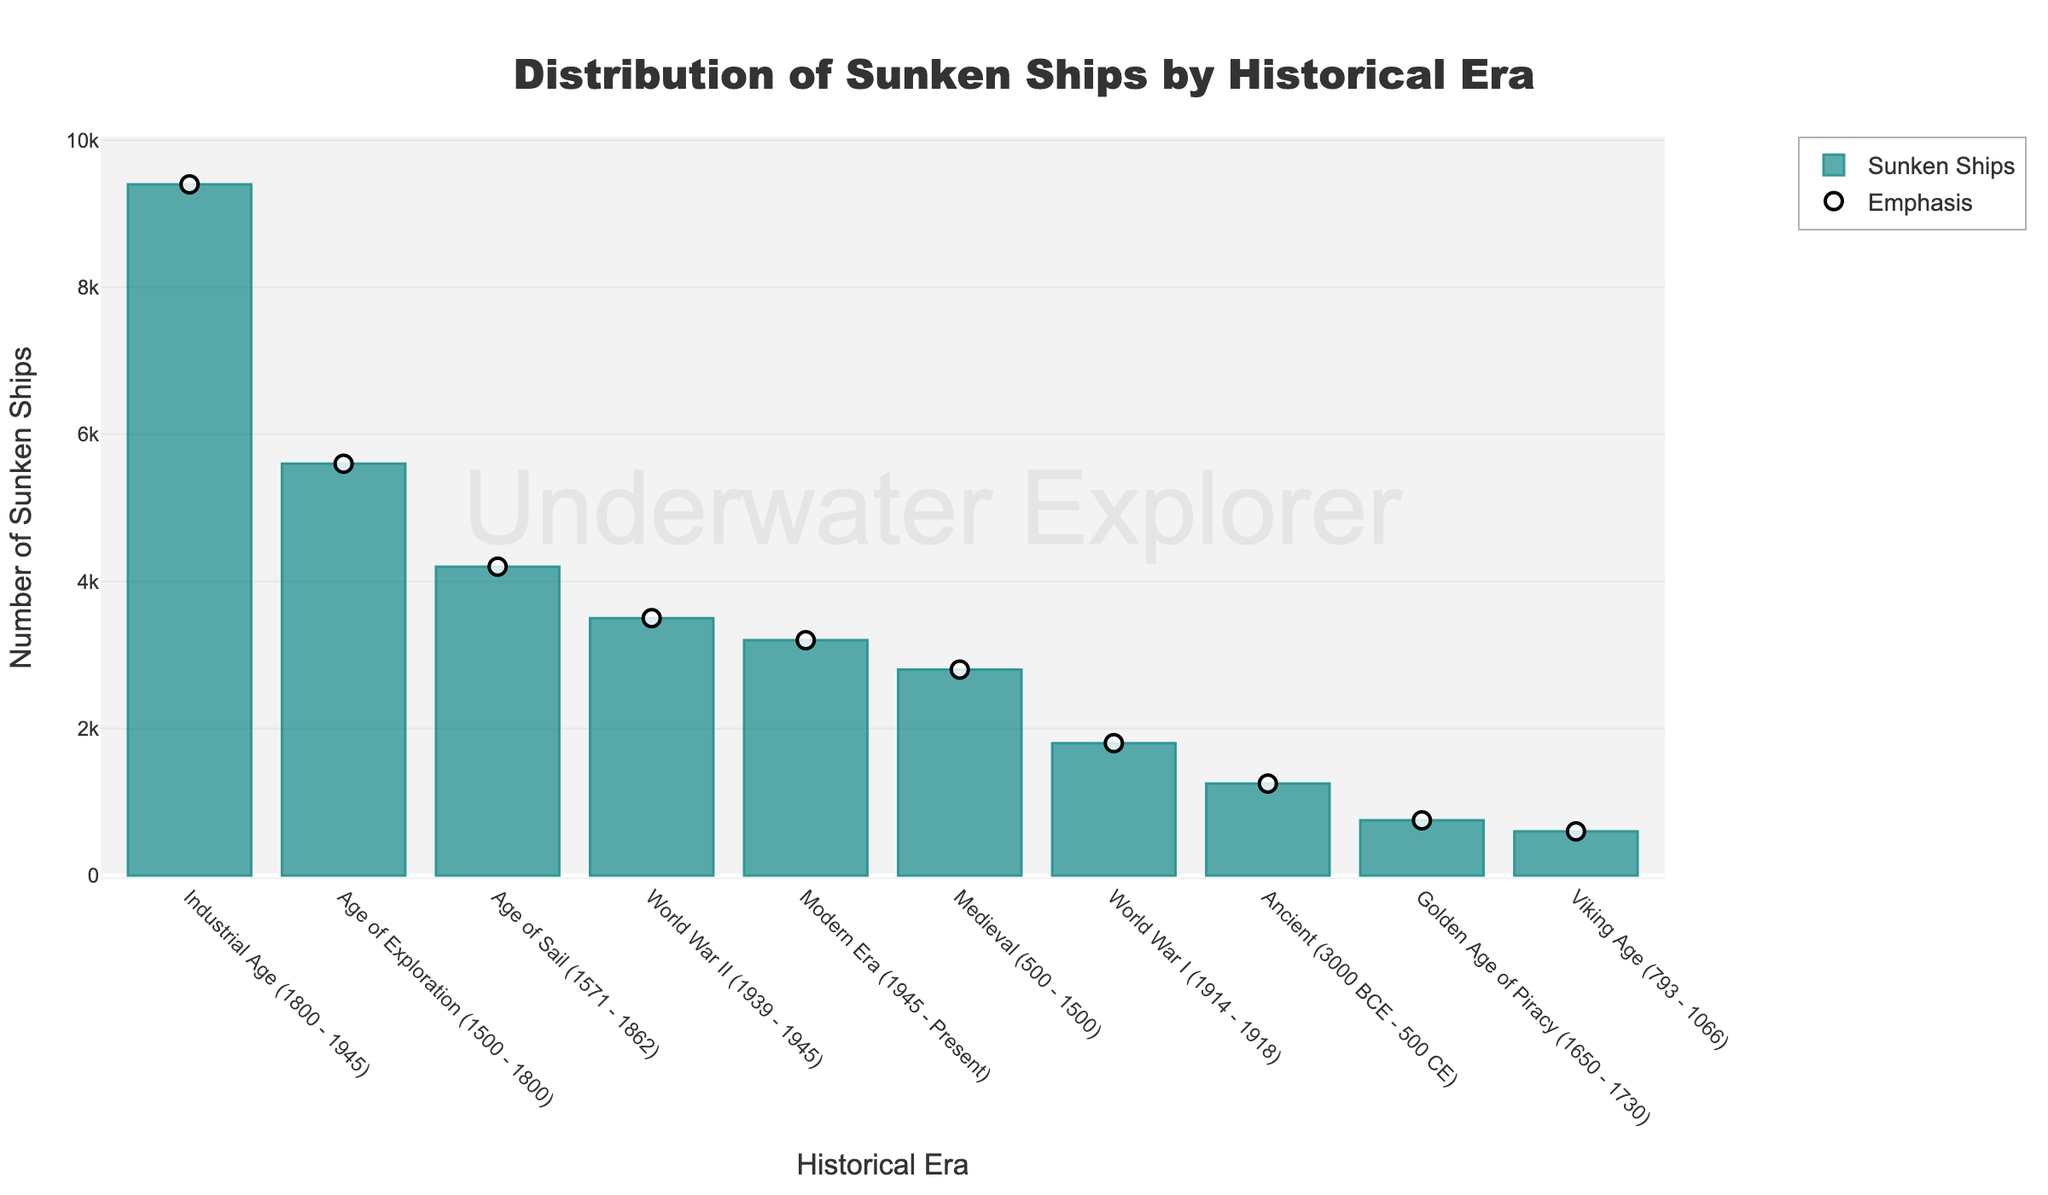What historical era has the highest number of sunken ships? Identify the tallest bar in the bar chart, which represents the era with the most sunken ships. The highest bar corresponds to the "Industrial Age (1800 - 1945)" with 9400 ships.
Answer: Industrial Age (1800 - 1945) Which two historical eras have the fewest sunken ships combined? Examine the bars and find the smallest bars. The "Viking Age (793 - 1066)" and the "Golden Age of Piracy (1650 - 1730)" have the fewest ships, with 600 and 750 ships respectively. Add these numbers: 600 + 750 = 1350 ships.
Answer: Viking Age and Golden Age of Piracy, 1350 ships How many more sunken ships are there in the Age of Exploration compared to the Medieval era? Locate the bars for the "Age of Exploration (1500 - 1800)" and "Medieval (500 - 1500)" eras. The number of sunken ships in these eras is 5600 and 2800 respectively. Subtract the smaller value from the larger: 5600 - 2800 = 2800 ships.
Answer: 2800 ships What is the average number of sunken ships in the Industrial Age, World War I, and World War II eras? Identify the bars for the "Industrial Age (1800 - 1945)" (9400 ships), "World War I (1914 - 1918)" (1800 ships), and "World War II (1939 - 1945)" (3500 ships). Add these numbers: 9400 + 1800 + 3500 = 14700 ships. Divide by the number of eras, which is 3: 14700 / 3 = 4900 ships.
Answer: 4900 ships Which era has fewer sunken ships: Modern Era or World War II? Compare the heights of the bars for "Modern Era (1945 - Present)" and "World War II (1939 - 1945)". The Modern Era has 3200 ships and World War II has 3500 ships. Since 3200 < 3500, the Modern Era has fewer sunken ships.
Answer: Modern Era In which era are the number of sunken ships closer to the median value of all the eras? First, determine the median value. List the number of ships in ascending order: 600, 750, 1250, 1800, 2800, 3200, 3500, 4200, 5600, 9400. The middle values are 2800 and 3200, so the median is (2800 + 3200) / 2 = 3000 ships. Assess which era's ship count is closest to 3000. The era closest to 3000 is the "Modern Era (1945 - Present)" with 3200 ships.
Answer: Modern Era (1945 - Present) Compare the number of sunken ships in the Ancient and Age of Sail eras; which one has more? Look at the bars for the "Ancient (3000 BCE - 500 CE)" and "Age of Sail (1571 - 1862)" eras. The Ancient era has 1250 ships, and the Age of Sail has 4200 ships. Since 4200 > 1250, the Age of Sail has more sunken ships.
Answer: Age of Sail What proportion of sunken ships occurred during the Age of Exploration out of the total number of ships in the Age of Exploration, Age of Sail, and Golden Age of Piracy combined? Add the number of ships in the Age of Exploration (5600), Age of Sail (4200), and Golden Age of Piracy (750): 5600 + 4200 + 750 = 10550. The proportion for the Age of Exploration is 5600 / 10550. Divide to get the answer: 5600 / 10550 ≈ 0.531, or 53.1%.
Answer: 53.1% 